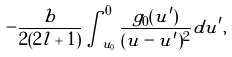<formula> <loc_0><loc_0><loc_500><loc_500>- \frac { b } { 2 ( 2 l + 1 ) } \int _ { u _ { 0 } } ^ { 0 } \frac { g _ { 0 } ( u ^ { \prime } ) } { ( u - u ^ { \prime } ) ^ { 2 } } d u ^ { \prime } ,</formula> 